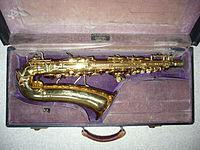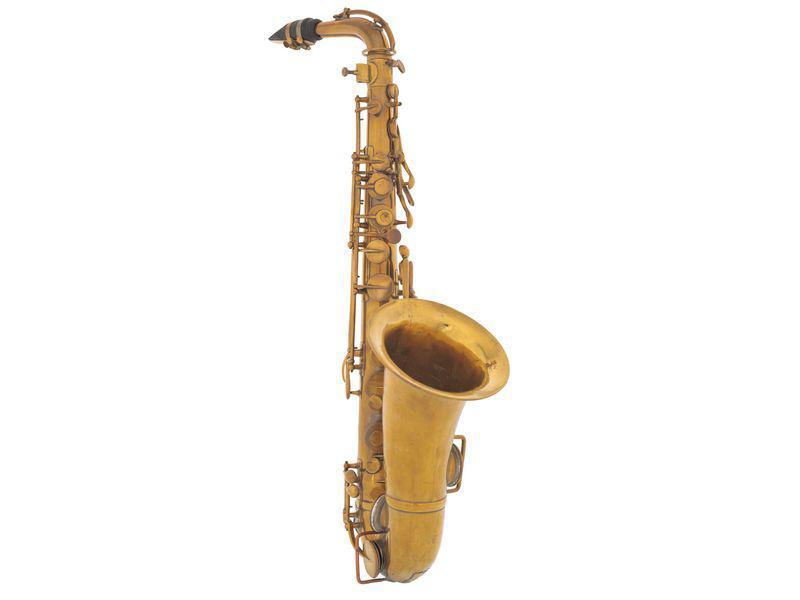The first image is the image on the left, the second image is the image on the right. For the images displayed, is the sentence "An image shows a brass colored instrument with an imperfect finish on a black background." factually correct? Answer yes or no. No. The first image is the image on the left, the second image is the image on the right. Evaluate the accuracy of this statement regarding the images: "One image shows a saxophone on a plain black background.". Is it true? Answer yes or no. No. 